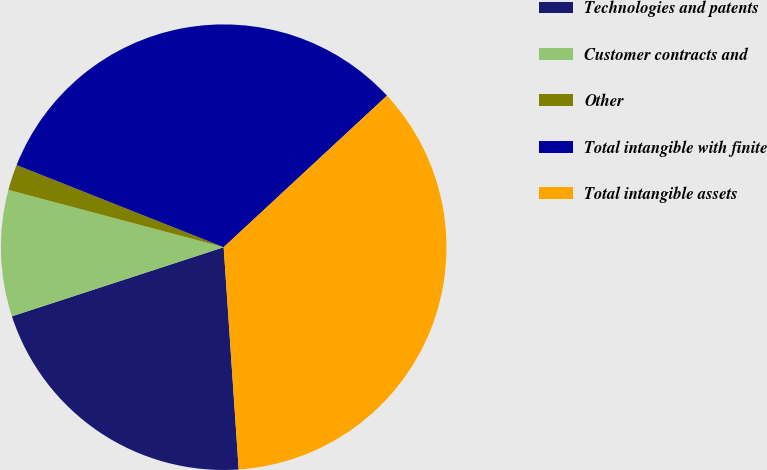Convert chart. <chart><loc_0><loc_0><loc_500><loc_500><pie_chart><fcel>Technologies and patents<fcel>Customer contracts and<fcel>Other<fcel>Total intangible with finite<fcel>Total intangible assets<nl><fcel>21.05%<fcel>9.16%<fcel>1.87%<fcel>32.08%<fcel>35.83%<nl></chart> 